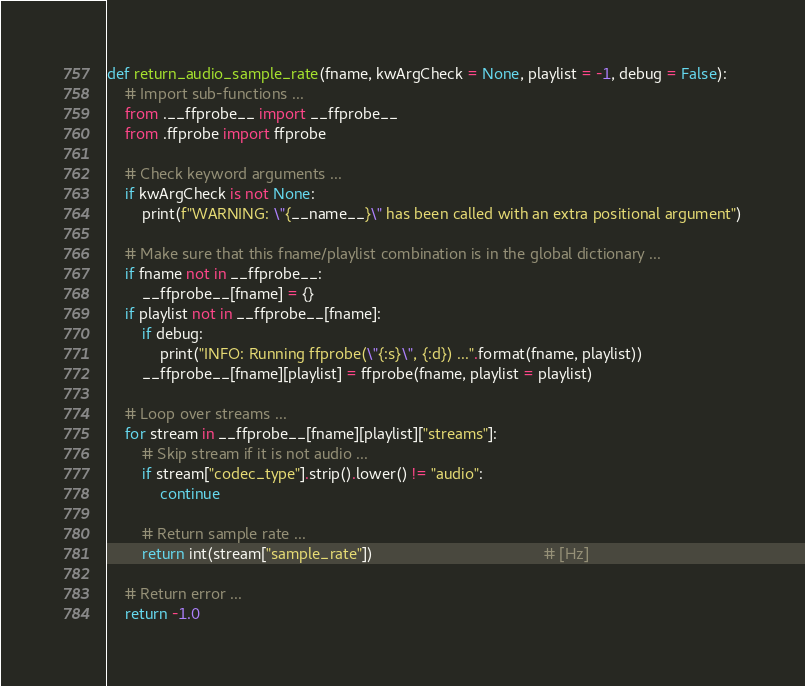Convert code to text. <code><loc_0><loc_0><loc_500><loc_500><_Python_>def return_audio_sample_rate(fname, kwArgCheck = None, playlist = -1, debug = False):
    # Import sub-functions ...
    from .__ffprobe__ import __ffprobe__
    from .ffprobe import ffprobe

    # Check keyword arguments ...
    if kwArgCheck is not None:
        print(f"WARNING: \"{__name__}\" has been called with an extra positional argument")

    # Make sure that this fname/playlist combination is in the global dictionary ...
    if fname not in __ffprobe__:
        __ffprobe__[fname] = {}
    if playlist not in __ffprobe__[fname]:
        if debug:
            print("INFO: Running ffprobe(\"{:s}\", {:d}) ...".format(fname, playlist))
        __ffprobe__[fname][playlist] = ffprobe(fname, playlist = playlist)

    # Loop over streams ...
    for stream in __ffprobe__[fname][playlist]["streams"]:
        # Skip stream if it is not audio ...
        if stream["codec_type"].strip().lower() != "audio":
            continue

        # Return sample rate ...
        return int(stream["sample_rate"])                                       # [Hz]

    # Return error ...
    return -1.0
</code> 